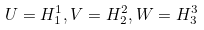<formula> <loc_0><loc_0><loc_500><loc_500>U = H _ { 1 } ^ { 1 } , V = H _ { 2 } ^ { 2 } , W = H _ { 3 } ^ { 3 }</formula> 